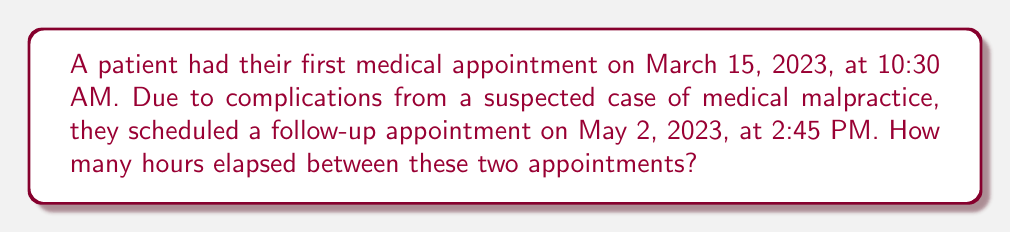Solve this math problem. To solve this problem, we need to calculate the time difference between the two appointments. Let's break it down step by step:

1. Convert the dates to a common format:
   First appointment: March 15, 2023, 10:30 AM
   Second appointment: May 2, 2023, 2:45 PM

2. Calculate the number of full days between the dates:
   March has 31 days, April has 30 days
   Full days = (31 - 15) + 30 + 2 = 48 days

3. Convert full days to hours:
   $48 \text{ days} \times 24 \text{ hours/day} = 1152 \text{ hours}$

4. Calculate the time difference on the partial days:
   From 10:30 AM on March 15 to midnight: $13.5 \text{ hours}$
   From midnight to 2:45 PM on May 2: $14.75 \text{ hours}$

5. Sum up all the hours:
   $\text{Total hours} = 1152 + 13.5 + 14.75 = 1180.25 \text{ hours}$

Therefore, the time elapsed between the two medical appointments is 1180.25 hours.
Answer: 1180.25 hours 